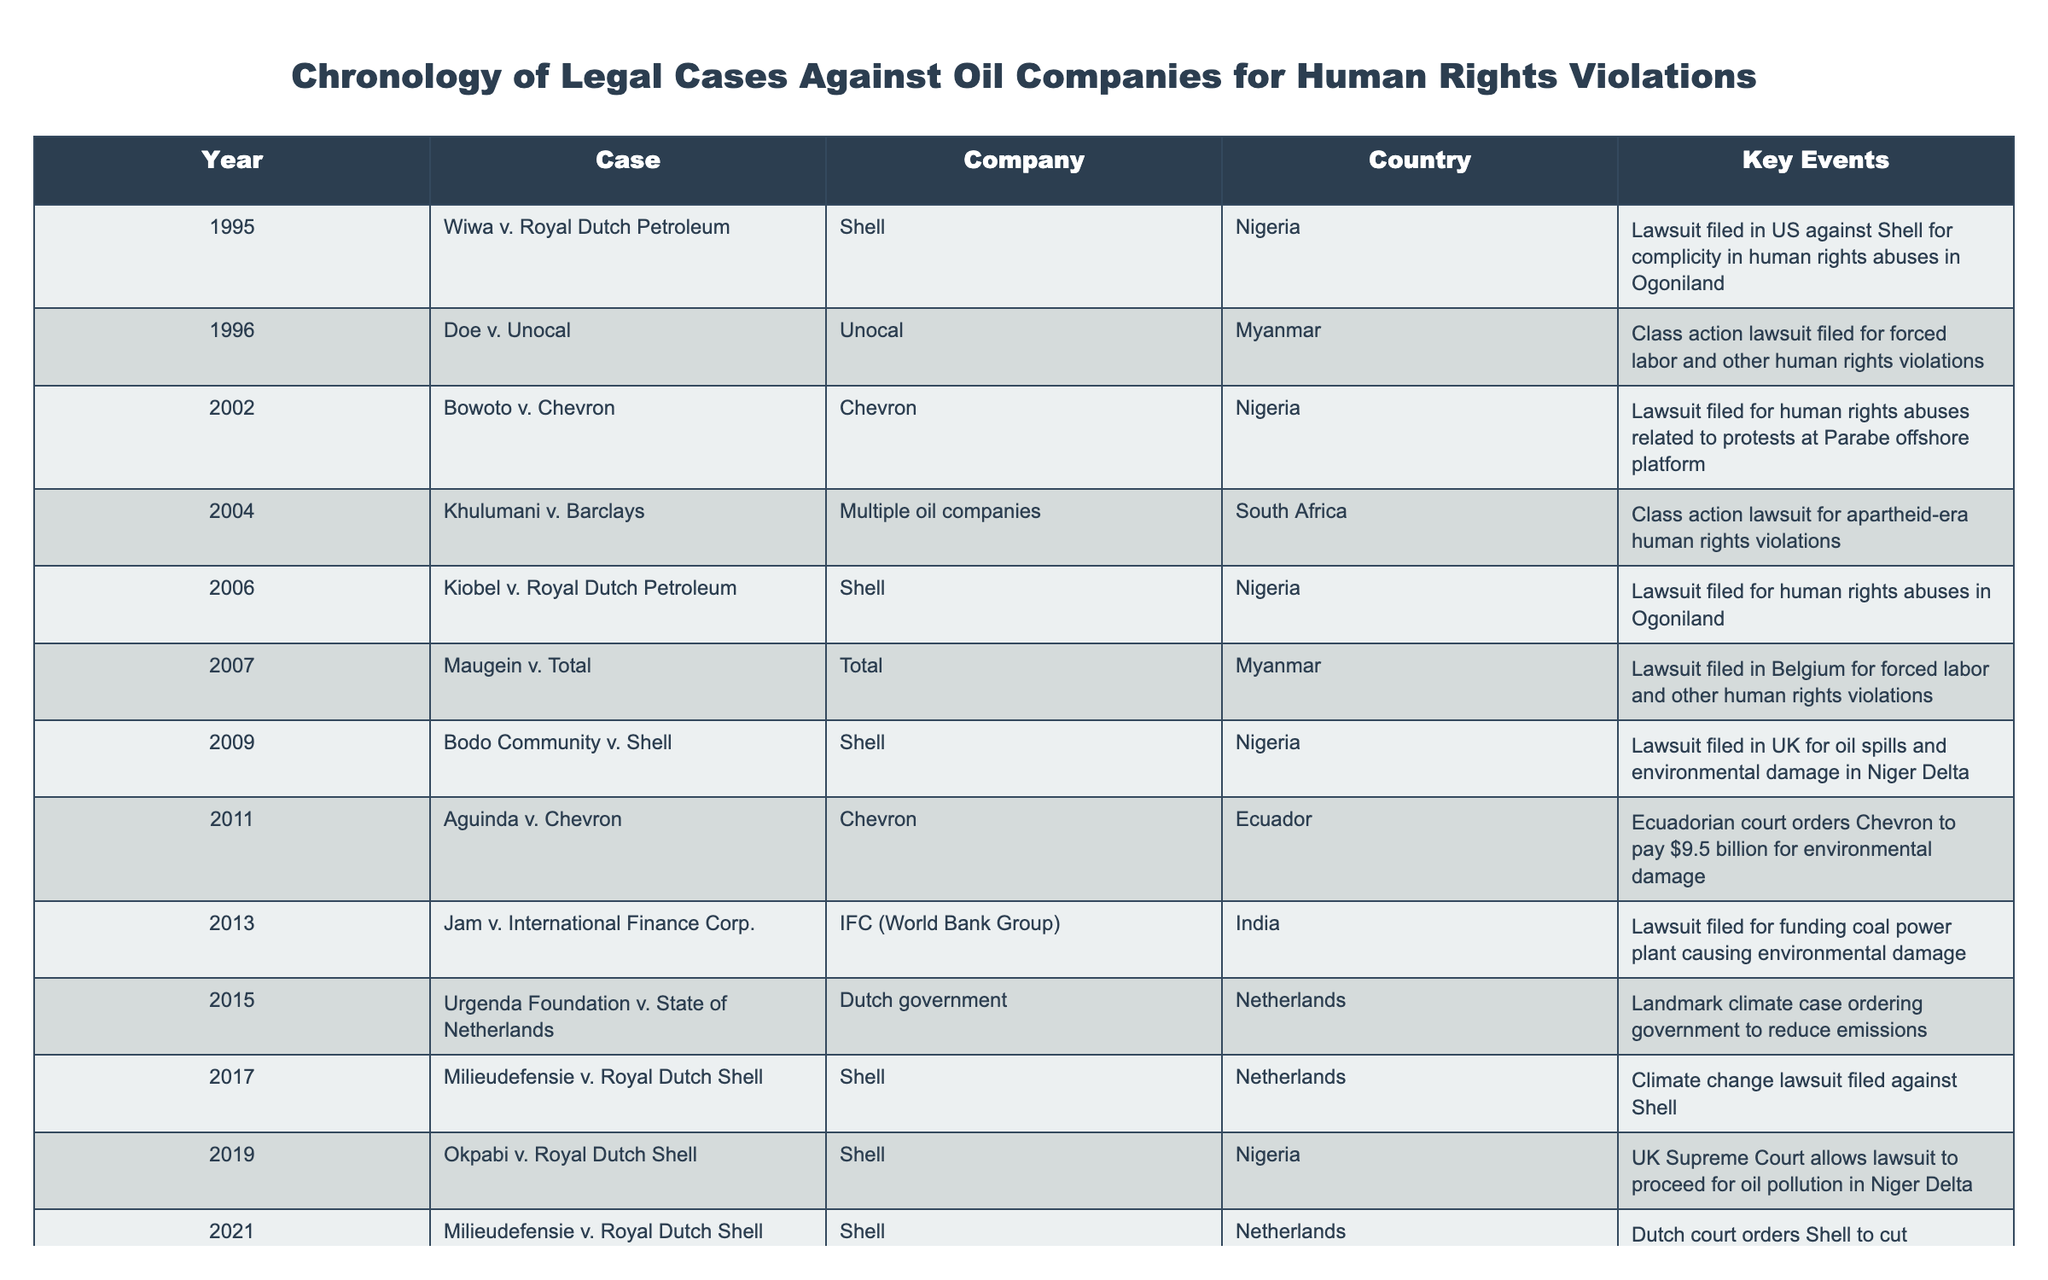What year was the Aguinda v. Chevron case filed? The table shows that the Aguinda v. Chevron case was filed in 2011. Thus, the specific year of the case can be directly retrieved from the "Year" column corresponding to this case.
Answer: 2011 Which company faced multiple lawsuits related to human rights violations in Nigeria? By examining the table, we can see that Shell has been involved in several cases including Wiwa v. Royal Dutch Petroleum, Bowoto v. Chevron, and others in connection with human rights violations in Nigeria. Thus, Shell is the company that faced multiple lawsuits related to Nigeria.
Answer: Shell Were there any legal cases against oil companies that resulted in a positive ruling for the complaintants? The table indicates that in the Aguinda v. Chevron case, the Ecuadorian court ordered Chevron to pay $9.5 billion for environmental damage, which suggests a ruling that favored the complaintants. Therefore, there is at least one case that resulted in a positive ruling.
Answer: Yes How many years passed between the first case listed and the most recent case? The first case listed is from 1995, and the most recent case is from 2023. To find the number of years that passed, we subtract 1995 from 2023: 2023 - 1995 = 28 years. Therefore, the span of years between the first and the most recent case is 28.
Answer: 28 Which country had the most legal cases against oil companies in this table? By reviewing the entries in the table, we can see that Nigeria has a total of 5 legal cases against oil companies including Wiwa v. Royal Dutch Petroleum, Bowoto v. Chevron, and others. Therefore, Nigeria had the most legal cases in this timeline.
Answer: Nigeria What was the outcome of the Milieudefensie v. Royal Dutch Shell case in 2021? According to the table, the outcome was that the Dutch court ordered Shell to cut emissions by 45% by 2030. This indicates a legal decision that sought to enforce emissions reductions from Shell.
Answer: Ordered Shell to cut emissions by 45% Did oil companies face any lawsuits in the Netherlands? Yes, the data shows multiple cases, including Milieudefensie v. Royal Dutch Shell, which indicates that oil companies did face lawsuits in the Netherlands.
Answer: Yes What is the total number of unique companies involved in the legal cases listed? The table features 6 unique companies: Shell, Unocal, Chevron, Total, RWE, and Suncor Energy. These can be counted across all the cases to determine their uniqueness.
Answer: 6 Were any of the cases filed in the United States? Yes, the table lists some cases filed in the United States such as Doe v. Unocal and Board of County Commissioners of Boulder County v. Suncor Energy, indicating that there were legal cases against oil companies in the U.S.
Answer: Yes 